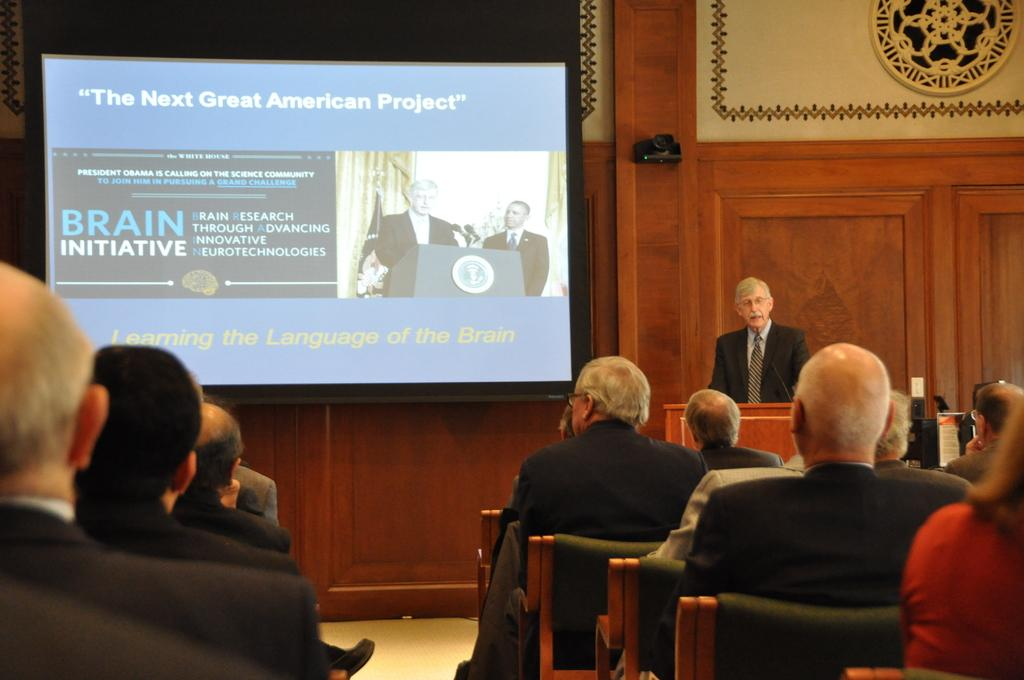What are the people in the image doing? There are persons sitting on chairs in the image. What can be seen beneath the people in the image? There is a floor visible in the image. What is the man in the image doing? There is a man standing on the floor in the image. What is visible in the background of the image? There is a wall and a screen in the background of the image. How many tickets can be seen on the floor in the image? There is no mention of tickets in the image; only chairs, a floor, a man, a wall, and a screen are present. 